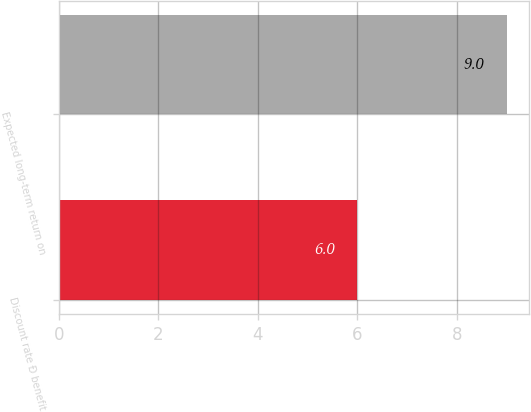Convert chart. <chart><loc_0><loc_0><loc_500><loc_500><bar_chart><fcel>Discount rate Ð benefit<fcel>Expected long-term return on<nl><fcel>6<fcel>9<nl></chart> 